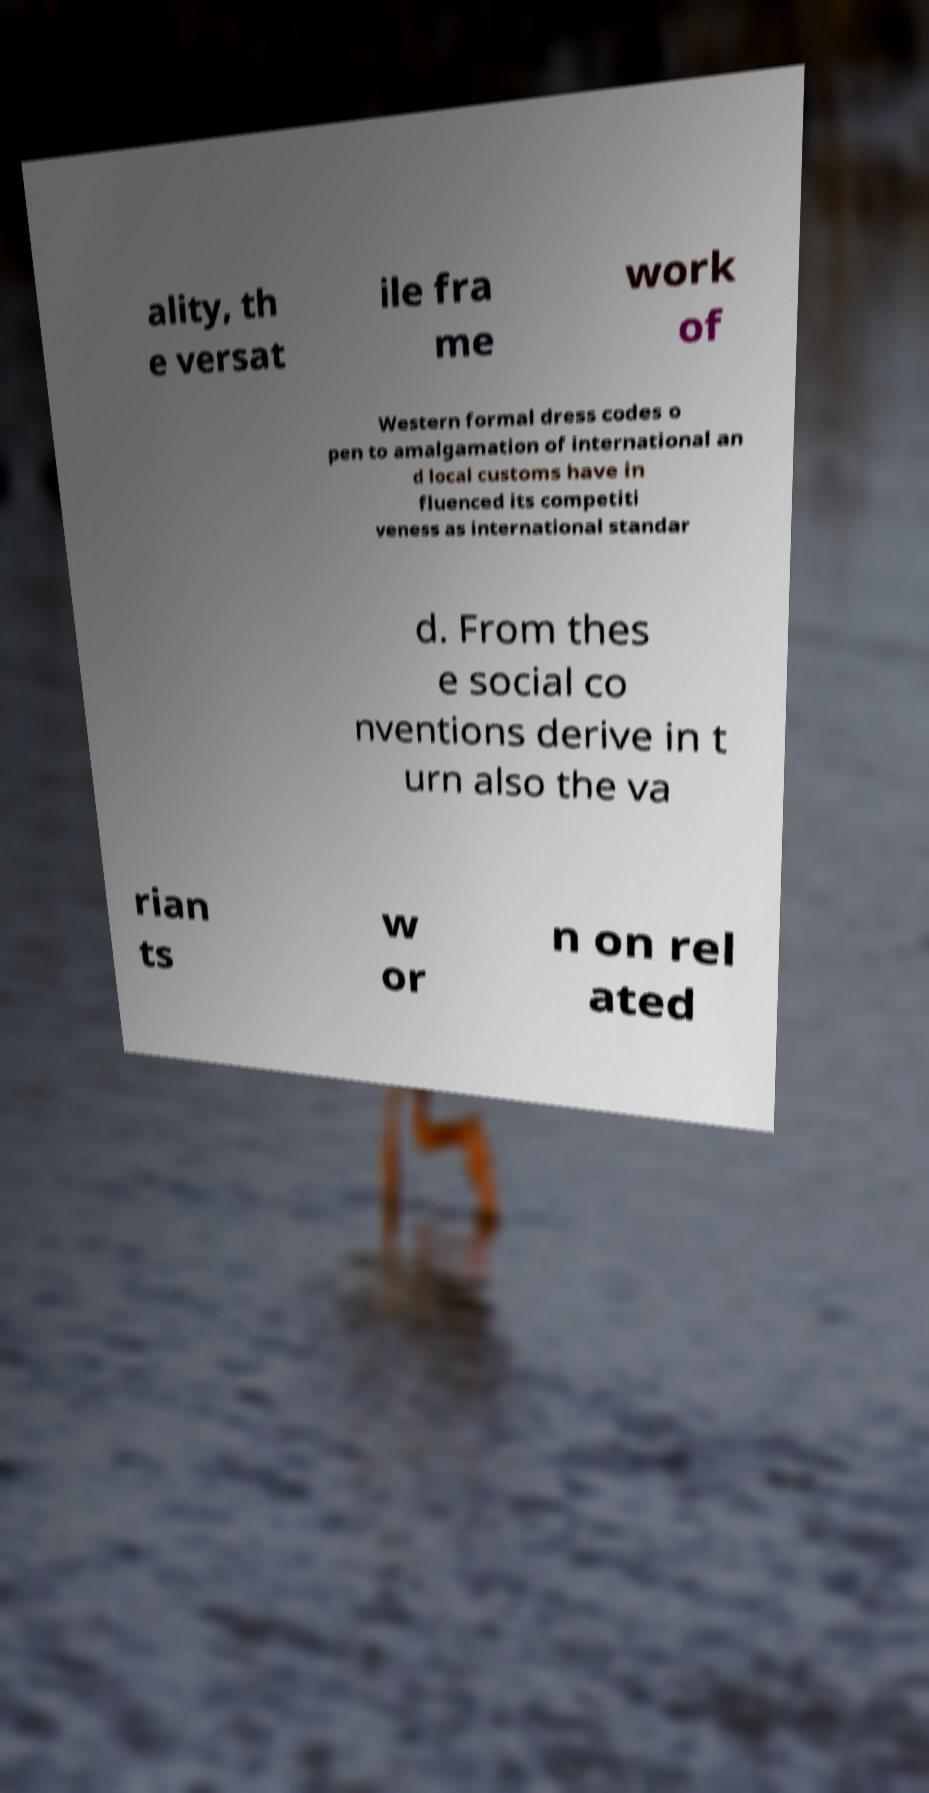Can you accurately transcribe the text from the provided image for me? ality, th e versat ile fra me work of Western formal dress codes o pen to amalgamation of international an d local customs have in fluenced its competiti veness as international standar d. From thes e social co nventions derive in t urn also the va rian ts w or n on rel ated 